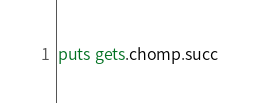<code> <loc_0><loc_0><loc_500><loc_500><_Ruby_>puts gets.chomp.succ</code> 